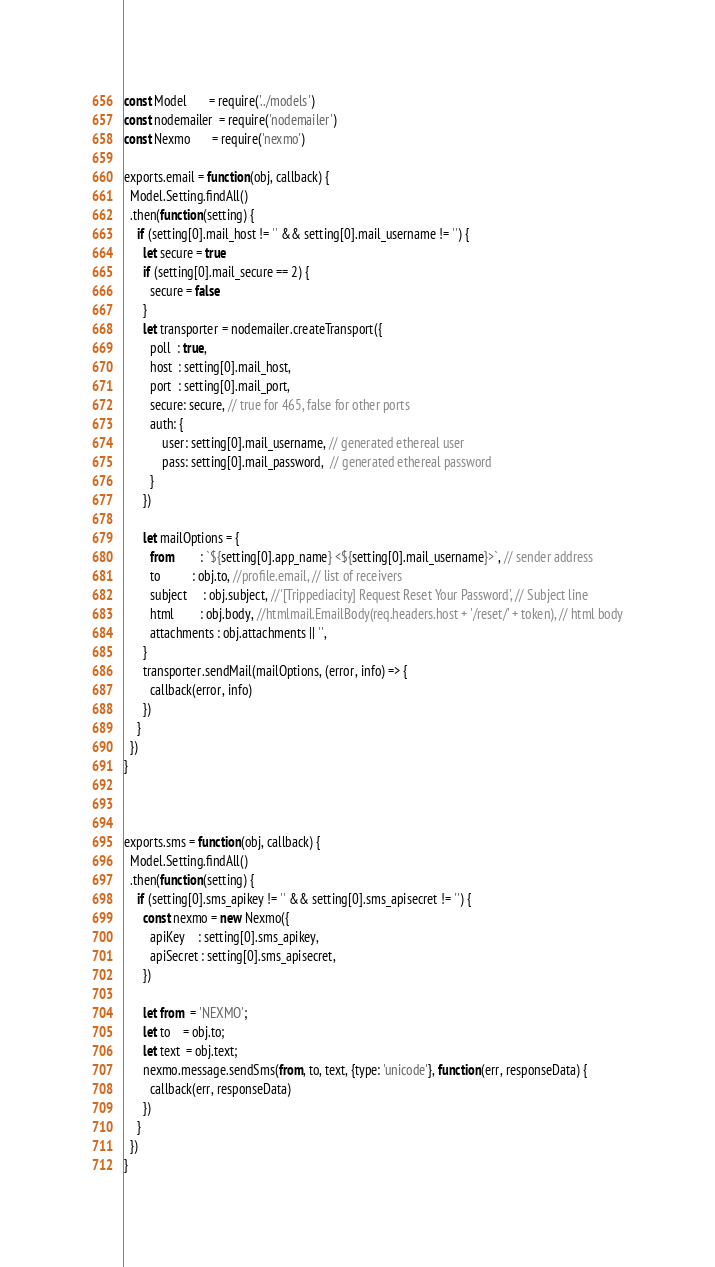Convert code to text. <code><loc_0><loc_0><loc_500><loc_500><_JavaScript_>const Model       = require('../models')
const nodemailer  = require('nodemailer')
const Nexmo       = require('nexmo')

exports.email = function(obj, callback) {
  Model.Setting.findAll()
  .then(function(setting) {
    if (setting[0].mail_host != '' && setting[0].mail_username != '') {
      let secure = true
      if (setting[0].mail_secure == 2) {
        secure = false
      }
      let transporter = nodemailer.createTransport({
        poll  : true,
        host  : setting[0].mail_host,
        port  : setting[0].mail_port,
        secure: secure, // true for 465, false for other ports
        auth: {
            user: setting[0].mail_username, // generated ethereal user
            pass: setting[0].mail_password,  // generated ethereal password
        }
      })

      let mailOptions = {
        from        : `${setting[0].app_name} <${setting[0].mail_username}>`, // sender address
        to          : obj.to, //profile.email, // list of receivers
        subject     : obj.subject, //'[Trippediacity] Request Reset Your Password', // Subject line
        html        : obj.body, //htmlmail.EmailBody(req.headers.host + '/reset/' + token), // html body
        attachments : obj.attachments || '',
      }
      transporter.sendMail(mailOptions, (error, info) => {
        callback(error, info)
      })
    }
  })
}



exports.sms = function(obj, callback) {
  Model.Setting.findAll()
  .then(function(setting) {
    if (setting[0].sms_apikey != '' && setting[0].sms_apisecret != '') {
      const nexmo = new Nexmo({
        apiKey    : setting[0].sms_apikey,
        apiSecret : setting[0].sms_apisecret,
      })

      let from  = 'NEXMO';
      let to    = obj.to;
      let text  = obj.text;
      nexmo.message.sendSms(from, to, text, {type: 'unicode'}, function(err, responseData) {
        callback(err, responseData)
      })
    }
  })
}
</code> 